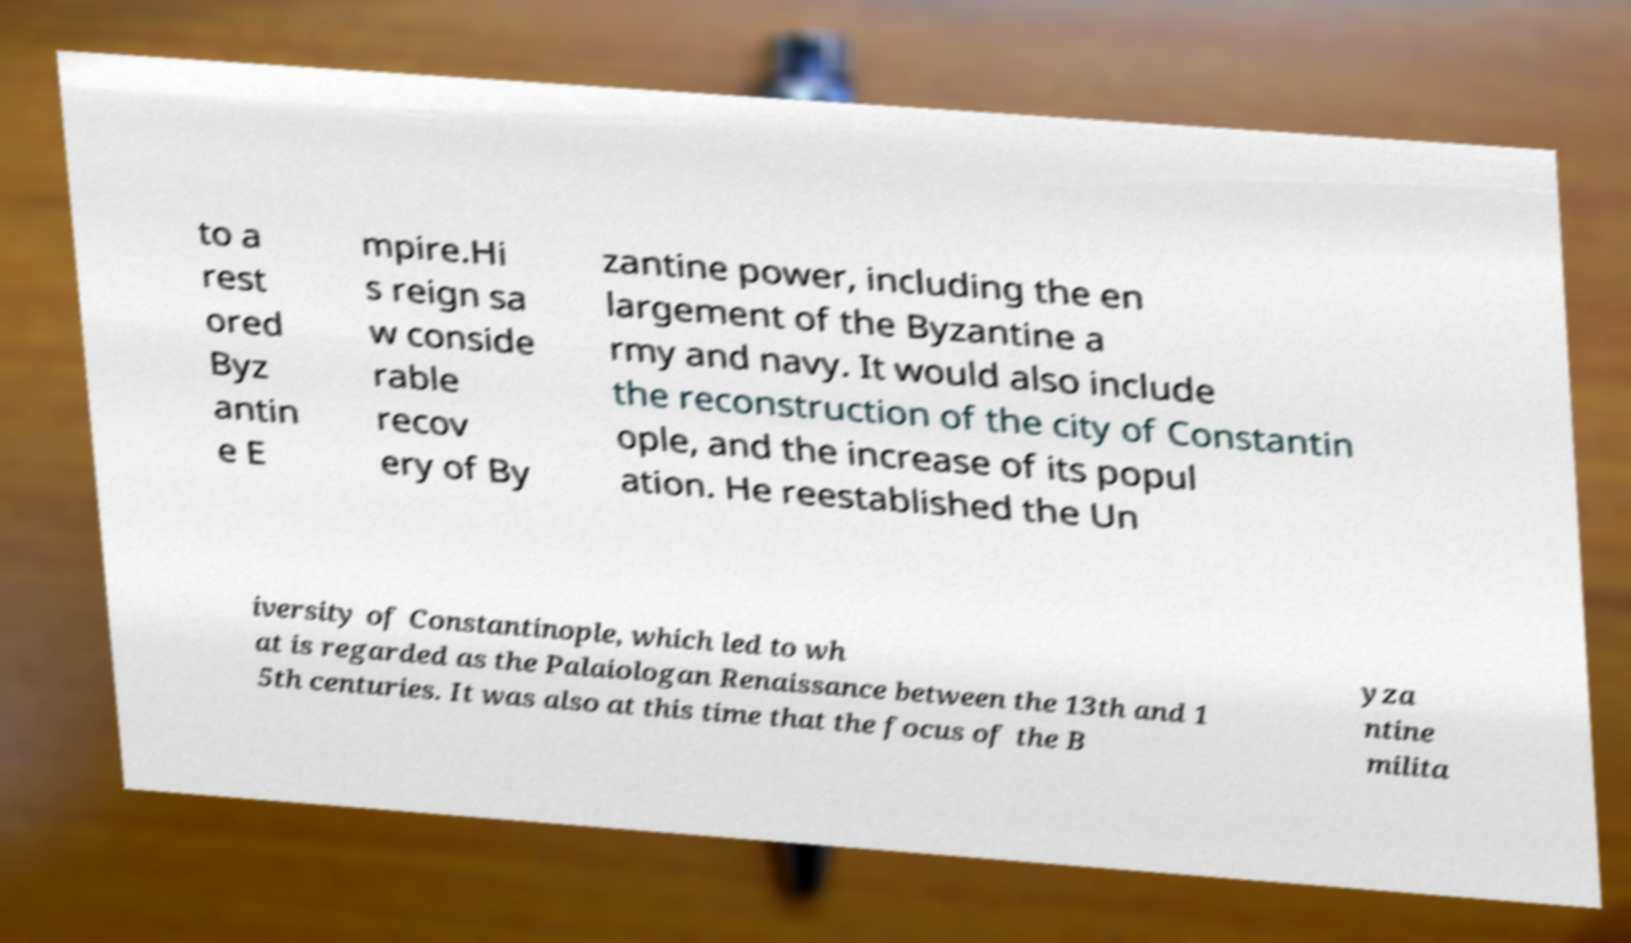Please read and relay the text visible in this image. What does it say? to a rest ored Byz antin e E mpire.Hi s reign sa w conside rable recov ery of By zantine power, including the en largement of the Byzantine a rmy and navy. It would also include the reconstruction of the city of Constantin ople, and the increase of its popul ation. He reestablished the Un iversity of Constantinople, which led to wh at is regarded as the Palaiologan Renaissance between the 13th and 1 5th centuries. It was also at this time that the focus of the B yza ntine milita 